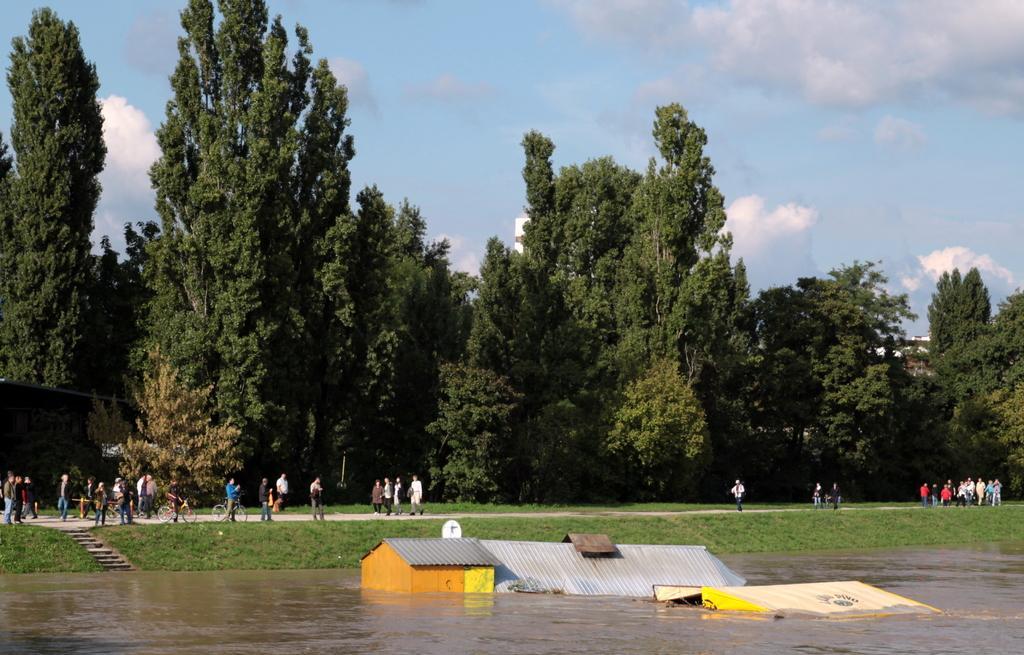Please provide a concise description of this image. In this picture I can see there are few buildings and there is water here. In the backdrop there is grass, stairs and there are few people walking here and there are trees and the sky is clear. 